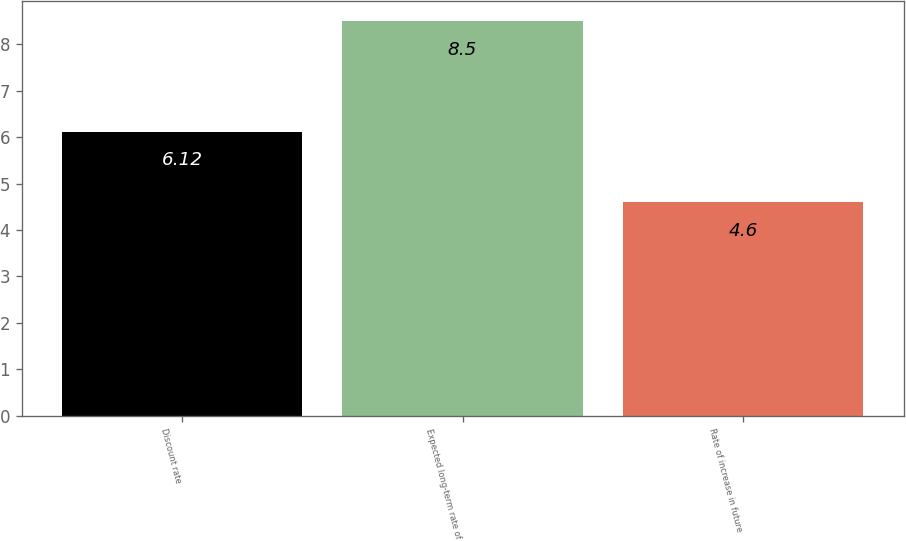<chart> <loc_0><loc_0><loc_500><loc_500><bar_chart><fcel>Discount rate<fcel>Expected long-term rate of<fcel>Rate of increase in future<nl><fcel>6.12<fcel>8.5<fcel>4.6<nl></chart> 